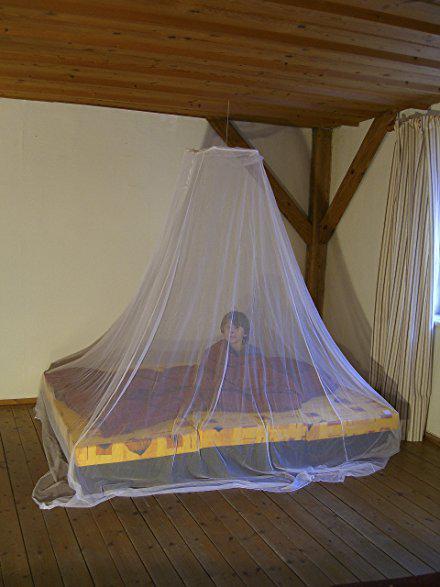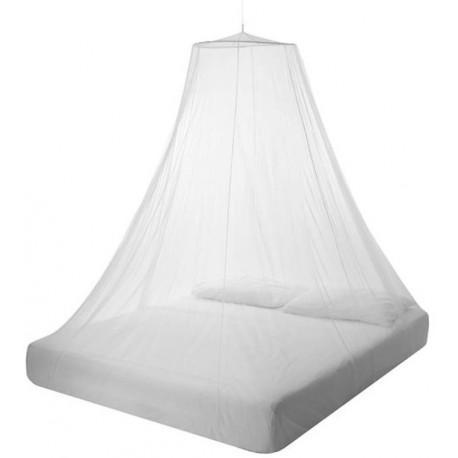The first image is the image on the left, the second image is the image on the right. For the images shown, is this caption "There are two beds." true? Answer yes or no. Yes. The first image is the image on the left, the second image is the image on the right. Assess this claim about the two images: "There are two canopies that cover a mattress.". Correct or not? Answer yes or no. Yes. 